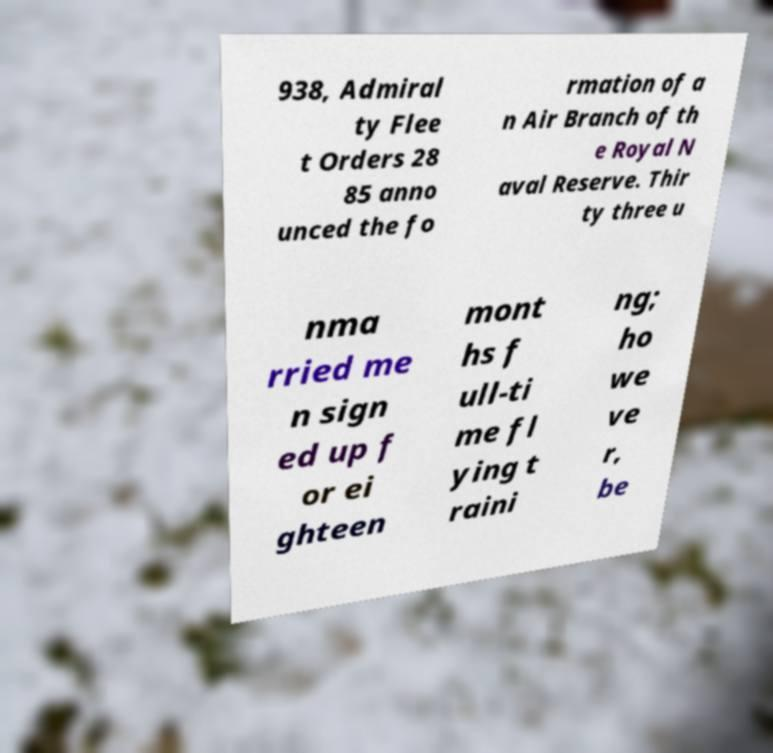What messages or text are displayed in this image? I need them in a readable, typed format. 938, Admiral ty Flee t Orders 28 85 anno unced the fo rmation of a n Air Branch of th e Royal N aval Reserve. Thir ty three u nma rried me n sign ed up f or ei ghteen mont hs f ull-ti me fl ying t raini ng; ho we ve r, be 